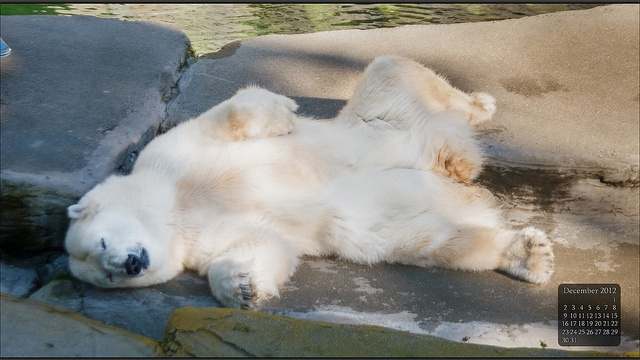Describe the objects in this image and their specific colors. I can see a bear in black, lightgray, darkgray, and tan tones in this image. 